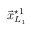Convert formula to latex. <formula><loc_0><loc_0><loc_500><loc_500>\vec { x } _ { L _ { 1 } } ^ { ^ { * } 1 }</formula> 